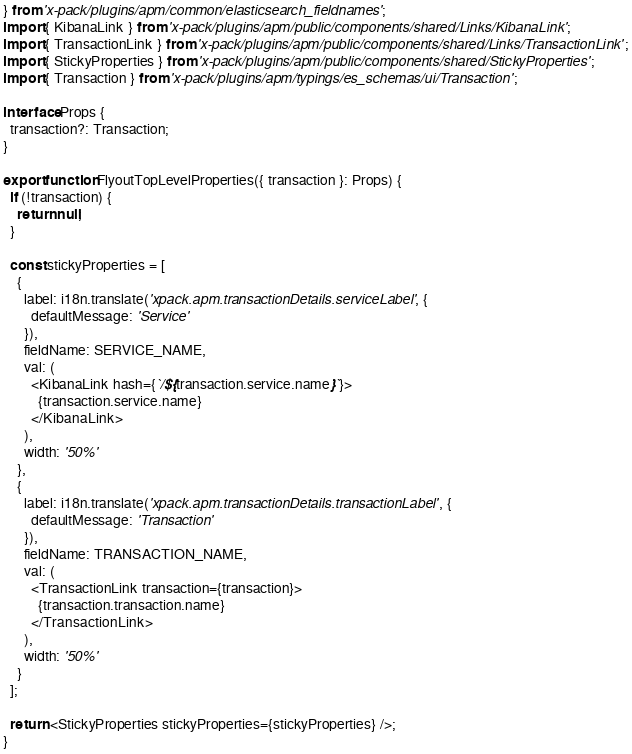Convert code to text. <code><loc_0><loc_0><loc_500><loc_500><_TypeScript_>} from 'x-pack/plugins/apm/common/elasticsearch_fieldnames';
import { KibanaLink } from 'x-pack/plugins/apm/public/components/shared/Links/KibanaLink';
import { TransactionLink } from 'x-pack/plugins/apm/public/components/shared/Links/TransactionLink';
import { StickyProperties } from 'x-pack/plugins/apm/public/components/shared/StickyProperties';
import { Transaction } from 'x-pack/plugins/apm/typings/es_schemas/ui/Transaction';

interface Props {
  transaction?: Transaction;
}

export function FlyoutTopLevelProperties({ transaction }: Props) {
  if (!transaction) {
    return null;
  }

  const stickyProperties = [
    {
      label: i18n.translate('xpack.apm.transactionDetails.serviceLabel', {
        defaultMessage: 'Service'
      }),
      fieldName: SERVICE_NAME,
      val: (
        <KibanaLink hash={`/${transaction.service.name}`}>
          {transaction.service.name}
        </KibanaLink>
      ),
      width: '50%'
    },
    {
      label: i18n.translate('xpack.apm.transactionDetails.transactionLabel', {
        defaultMessage: 'Transaction'
      }),
      fieldName: TRANSACTION_NAME,
      val: (
        <TransactionLink transaction={transaction}>
          {transaction.transaction.name}
        </TransactionLink>
      ),
      width: '50%'
    }
  ];

  return <StickyProperties stickyProperties={stickyProperties} />;
}
</code> 